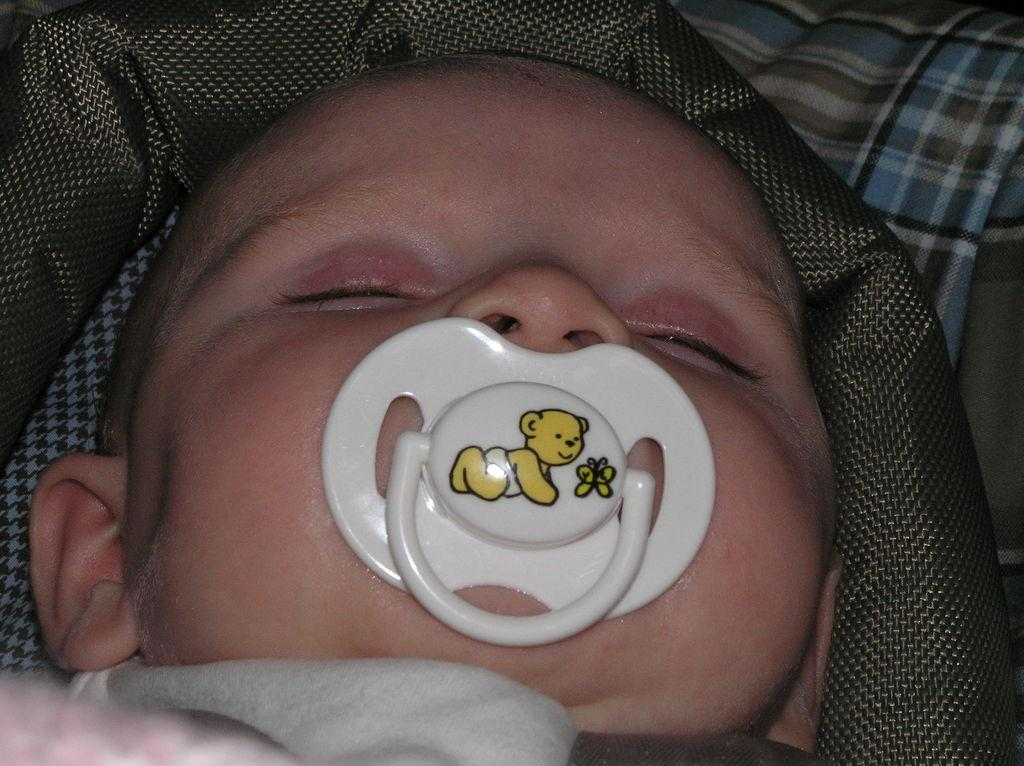What is the main subject of the image? There is a baby in the image. What is the baby holding in their mouth? The baby has a pacifier. What can be seen in the background of the image? There are clothes in the background of the image. What type of mask is the baby wearing in the image? There is no mask present in the image; the baby has a pacifier in their mouth. 